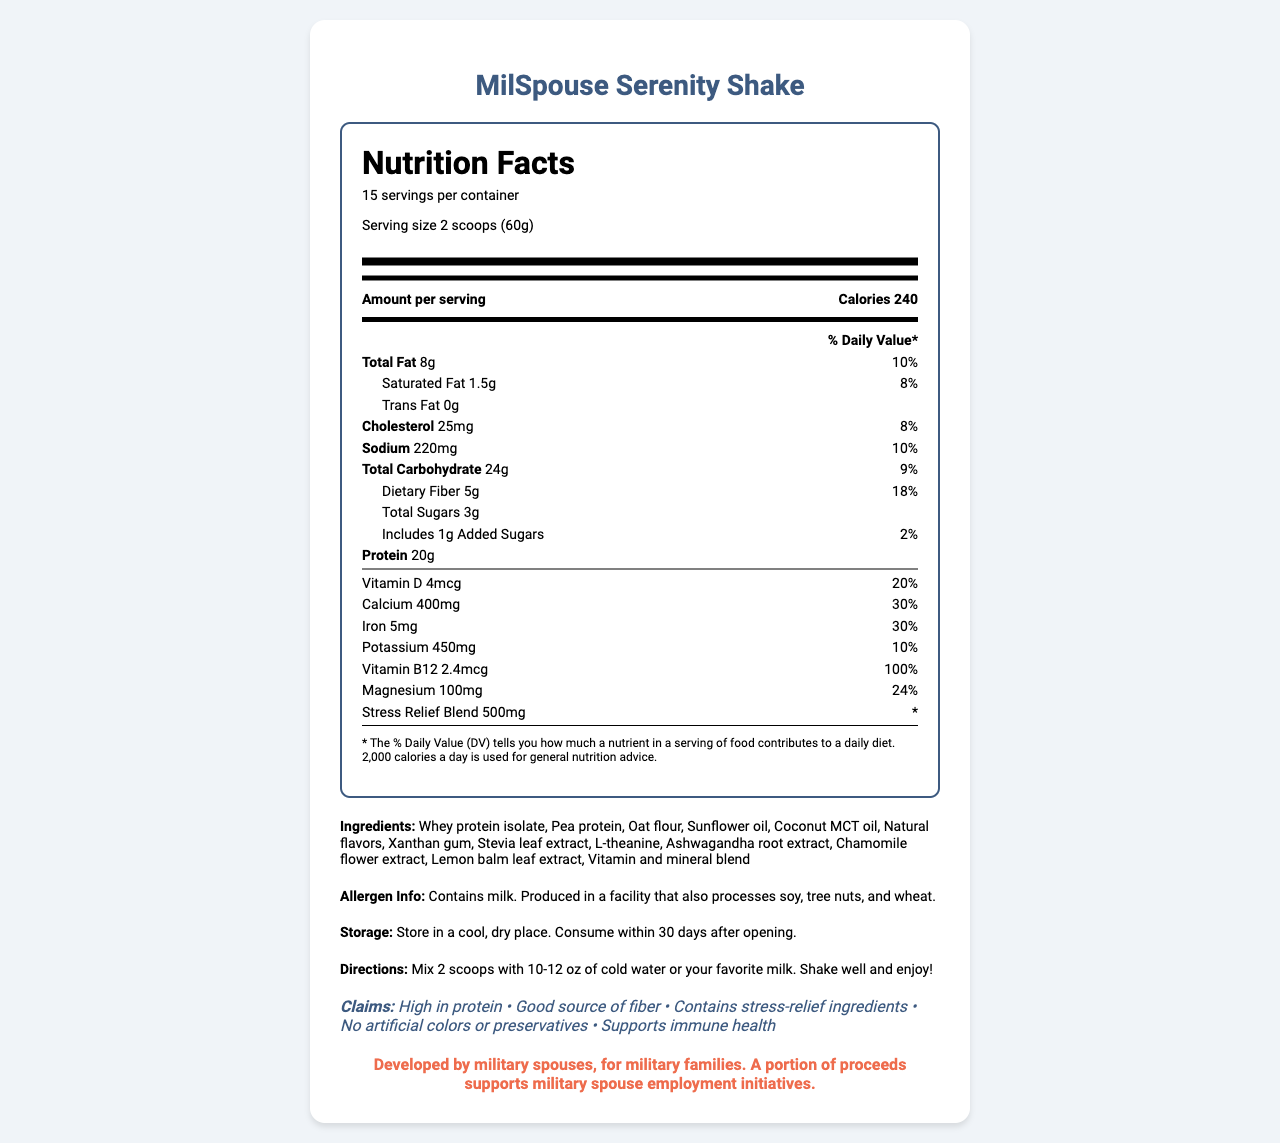what is the serving size of the MilSpouse Serenity Shake? The serving size is listed as "2 scoops (60g)" in the nutrition facts section.
Answer: 2 scoops (60g) how many calories are in one serving? The calories per serving are listed as 240 in the nutrition facts section.
Answer: 240 what is the total fat content in one serving? The total fat content is listed as 8g per serving in the nutrition label.
Answer: 8g which vitamins are included in the shake? The vitamins included are listed under the nutrients section: Vitamin D and Vitamin B12.
Answer: Vitamin D, Vitamin B12 what is the amount of protein per serving? The amount of protein per serving is listed as 20g in the nutrition facts section.
Answer: 20g how many servings are in one container? The document states there are 15 servings per container under the nutrition facts.
Answer: 15 does the shake contain any allergens? The allergen information lists that the product contains milk and is produced in a facility that also processes soy, tree nuts, and wheat.
Answer: Yes what is the daily value percentage of calcium in one serving? A. 20% B. 30% C. 40% The daily value percentage for calcium is listed as 30% in the nutrition facts section.
Answer: B how is the shake prepared? A. Mix with hot water B. Mix with cold water or milk C. Blend with ice The directions specify, "Mix 2 scoops with 10-12 oz of cold water or your favorite milk. Shake well and enjoy!"
Answer: B what are the stress-relief ingredients in the shake? These ingredients are listed under the ingredients section as part of the stress-relief blend.
Answer: L-theanine, Ashwagandha root extract, Chamomile flower extract, Lemon balm leaf extract should the shake be stored in a refrigerator? The storage instructions state to store in a cool, dry place, not necessarily a refrigerator.
Answer: No what claim is made about the shake regarding diet? A. Low in fat B. High in protein C. Zero calories One of the claims listed under "claims" is that the shake is high in protein.
Answer: B does the shake contain artificial colors or preservatives? Yes/No The claims section explicitly states that the product contains no artificial colors or preservatives.
Answer: No summarize the main features of the MilSpouse Serenity Shake. The document describes all key features, ingredients, nutritional information, and special notes related to the MilSpouse Serenity Shake.
Answer: The MilSpouse Serenity Shake is a high-protein, nutrient-rich meal replacement developed by military spouses. It includes stress-relief ingredients like L-theanine and ashwagandha, and is free of artificial colors and preservatives. The shake supports immune health, is a good source of fiber, and is designed to cater to the needs of military families. what is the total carbohydrate content in two servings? Since one serving contains 24g of total carbohydrates, two servings would contain 48g.
Answer: 48g what is the specific amount of added sugars in the shake? The nutrition facts state that the shake includes 1g of added sugars.
Answer: 1g 